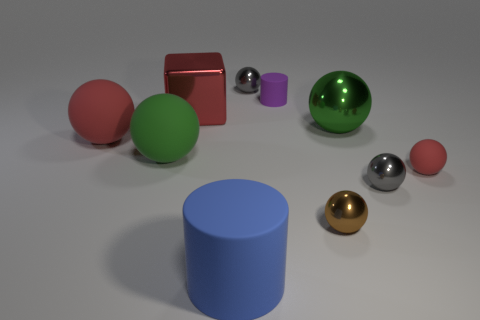Subtract all small gray spheres. How many spheres are left? 5 Subtract 4 spheres. How many spheres are left? 3 Subtract all brown balls. How many balls are left? 6 Subtract all cyan balls. Subtract all purple cubes. How many balls are left? 7 Subtract all cylinders. How many objects are left? 8 Add 1 tiny gray balls. How many tiny gray balls exist? 3 Subtract 0 yellow balls. How many objects are left? 10 Subtract all large blue matte objects. Subtract all tiny matte things. How many objects are left? 7 Add 3 large objects. How many large objects are left? 8 